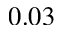<formula> <loc_0><loc_0><loc_500><loc_500>0 . 0 3</formula> 